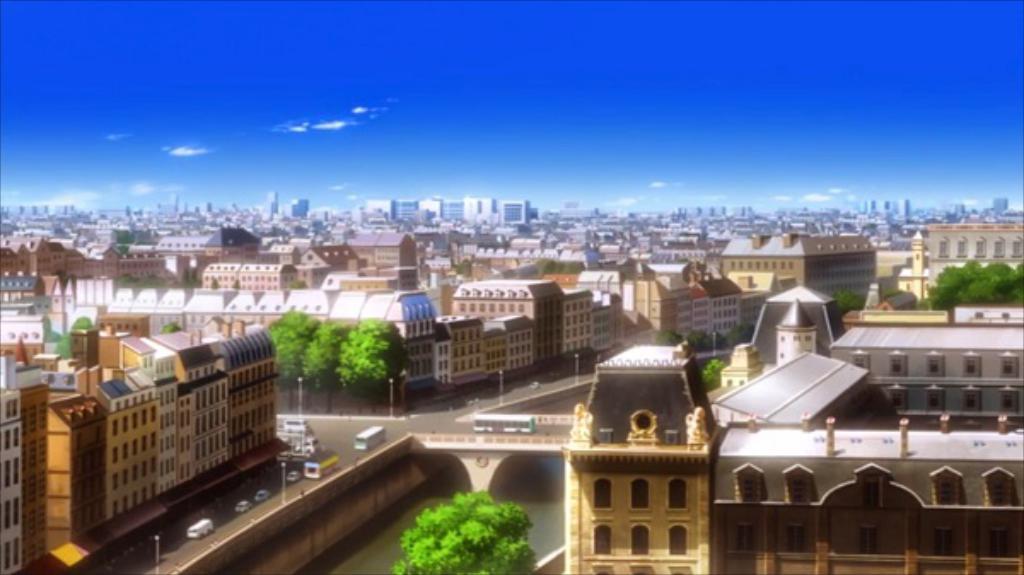Please provide a concise description of this image. In the center of the image there is water. There are vehicles on the bridge. In the background of the image there are trees, buildings, street lights and sky. 